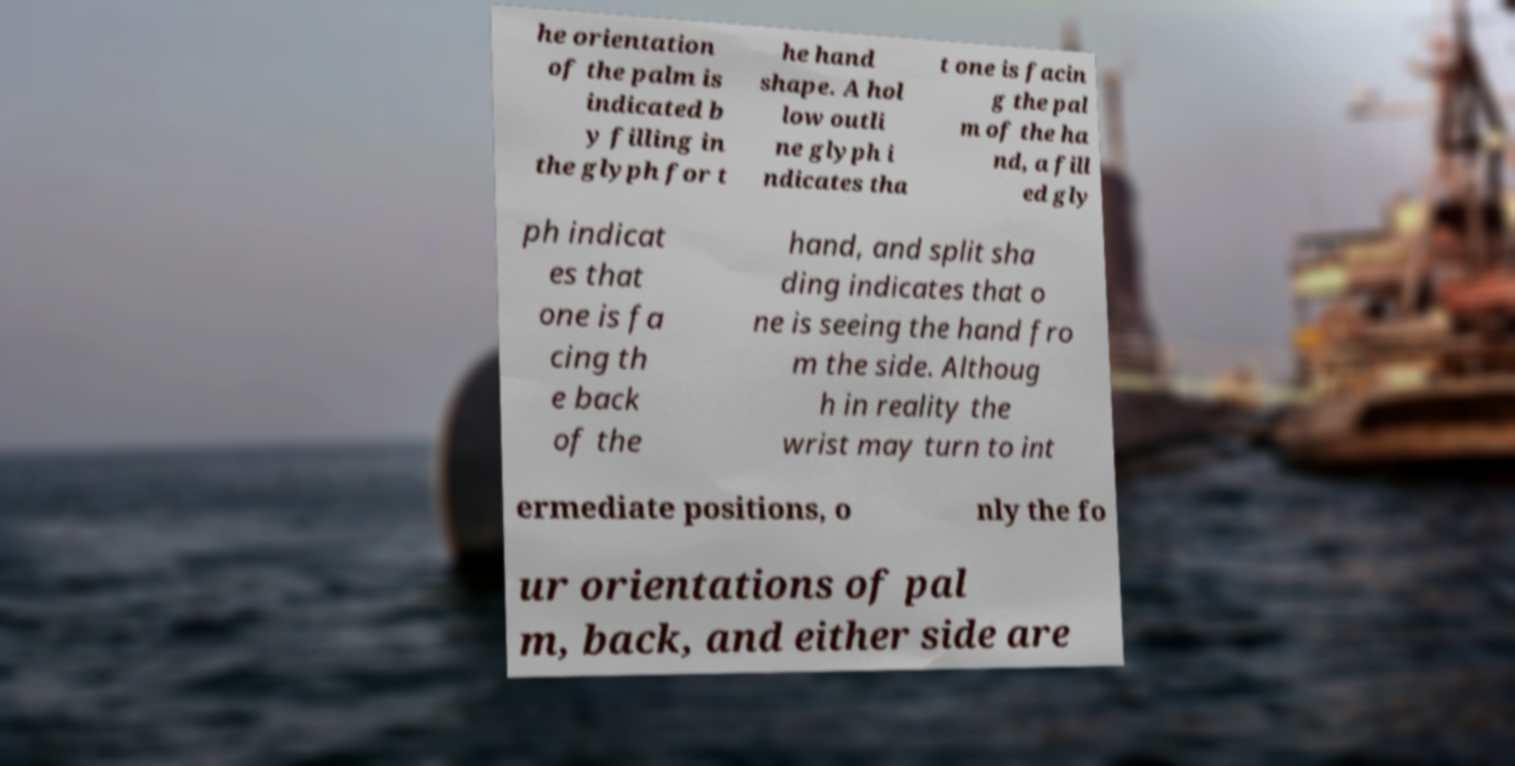For documentation purposes, I need the text within this image transcribed. Could you provide that? he orientation of the palm is indicated b y filling in the glyph for t he hand shape. A hol low outli ne glyph i ndicates tha t one is facin g the pal m of the ha nd, a fill ed gly ph indicat es that one is fa cing th e back of the hand, and split sha ding indicates that o ne is seeing the hand fro m the side. Althoug h in reality the wrist may turn to int ermediate positions, o nly the fo ur orientations of pal m, back, and either side are 